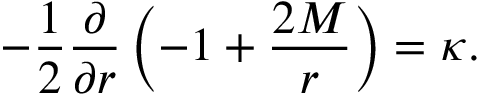Convert formula to latex. <formula><loc_0><loc_0><loc_500><loc_500>- { \frac { 1 } { 2 } } { \frac { \partial } { \partial r } } \left ( - 1 + { \frac { 2 M } { r } } \right ) = \kappa .</formula> 